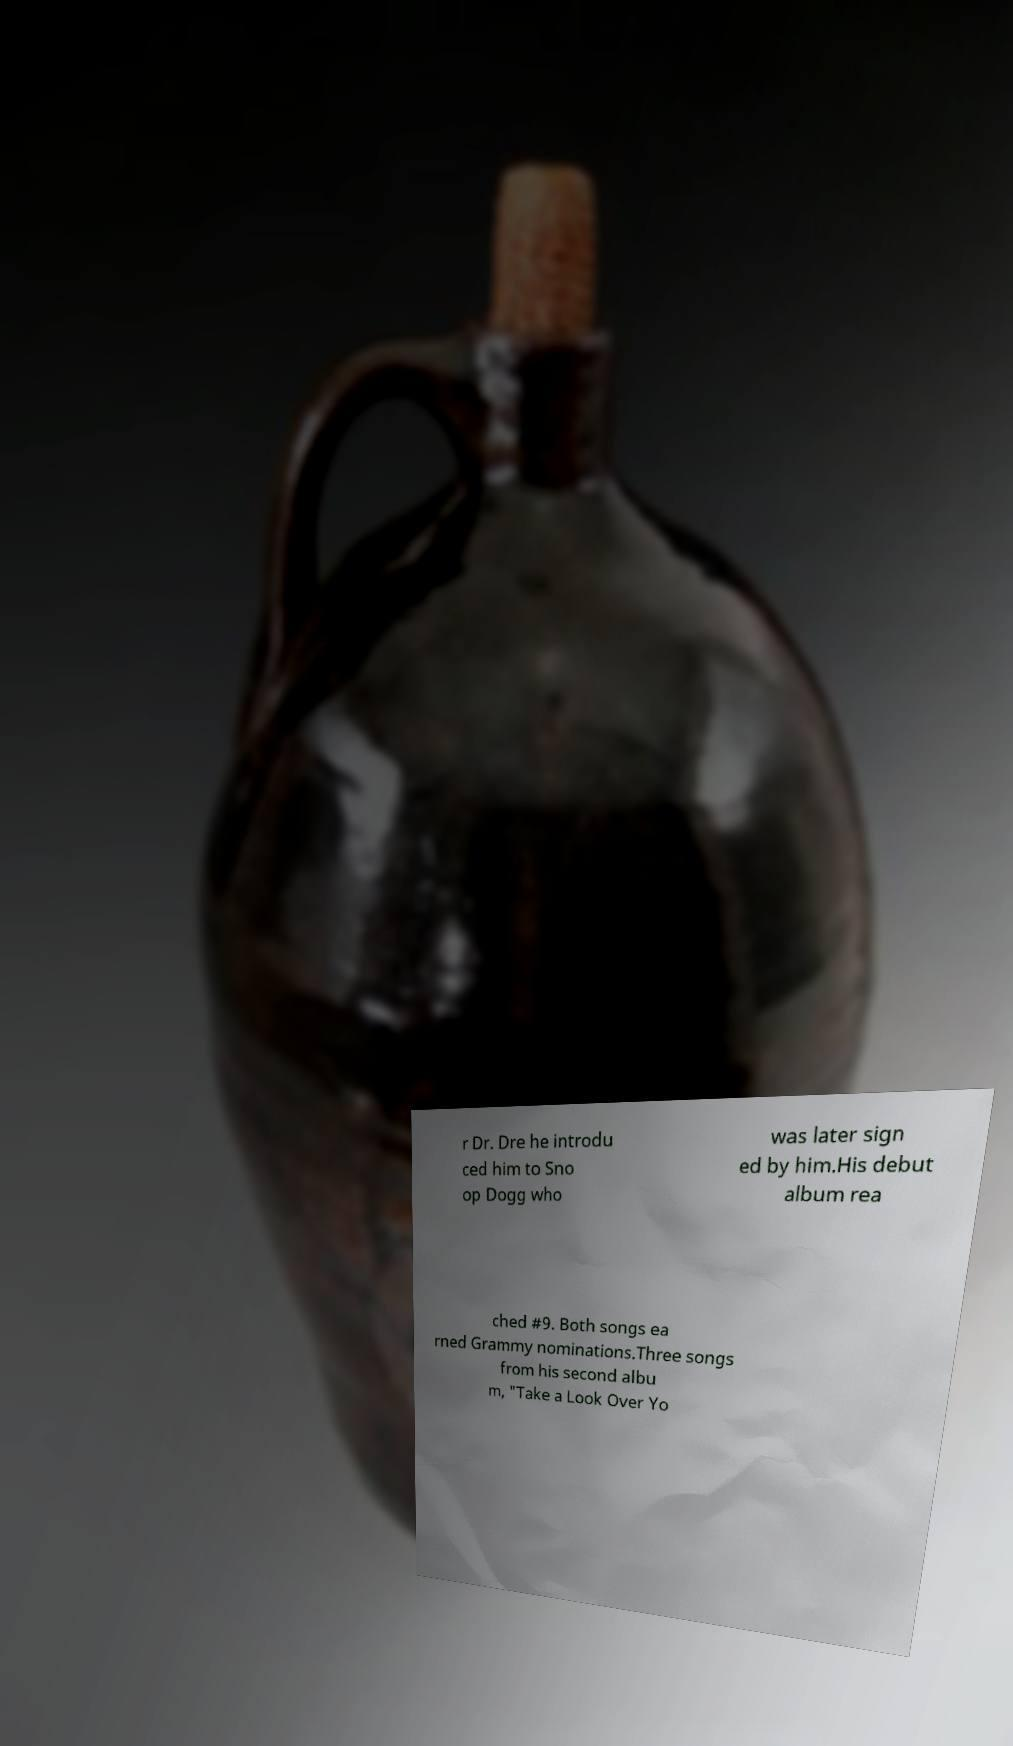What messages or text are displayed in this image? I need them in a readable, typed format. r Dr. Dre he introdu ced him to Sno op Dogg who was later sign ed by him.His debut album rea ched #9. Both songs ea rned Grammy nominations.Three songs from his second albu m, "Take a Look Over Yo 